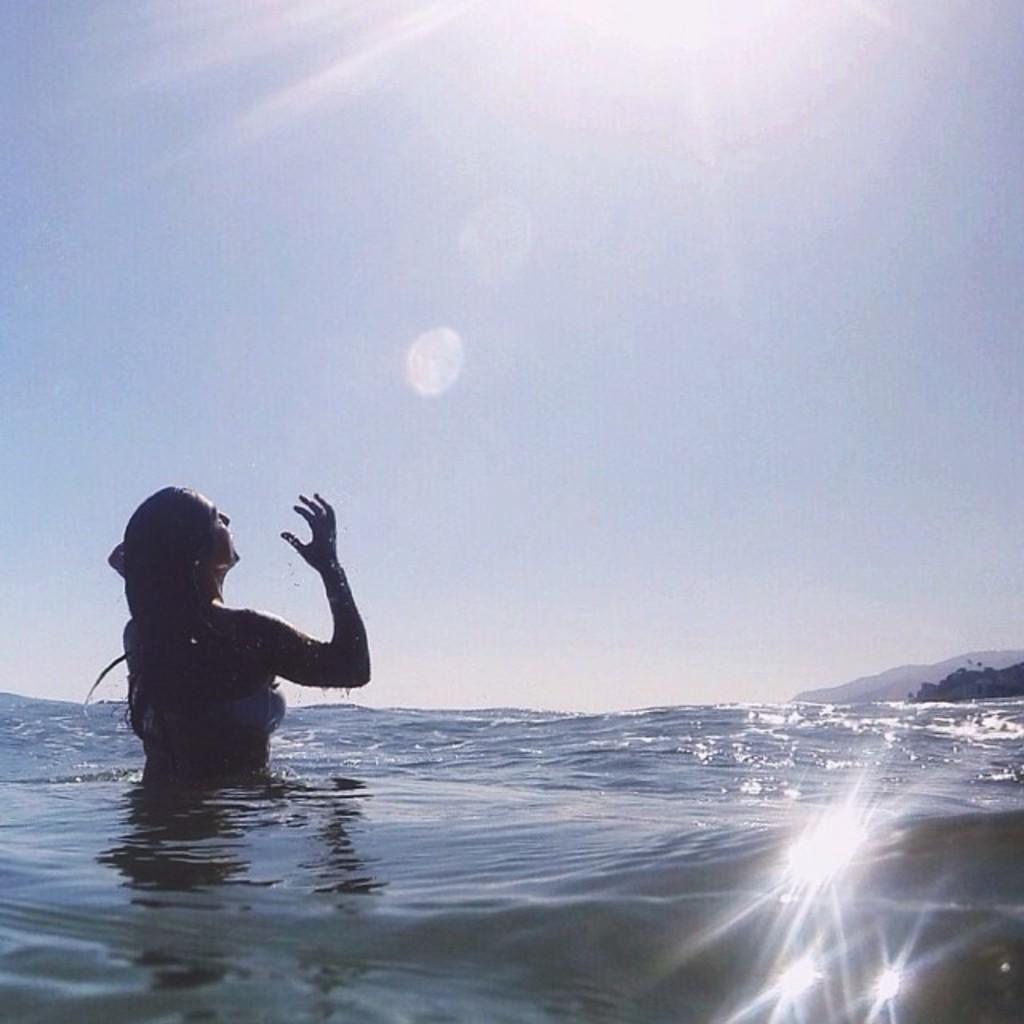Can you describe this image briefly? A woman is taking bath in the water and the sunlight is falling on her. 